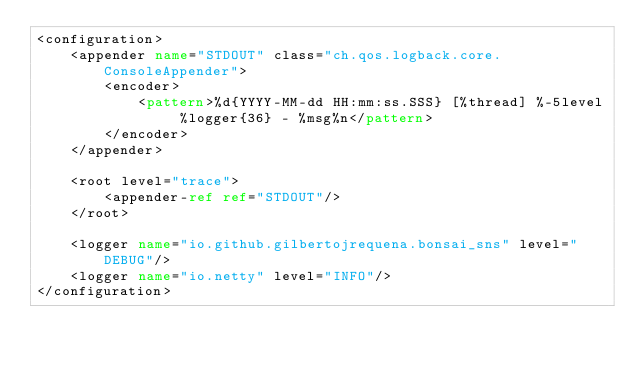<code> <loc_0><loc_0><loc_500><loc_500><_XML_><configuration>
    <appender name="STDOUT" class="ch.qos.logback.core.ConsoleAppender">
        <encoder>
            <pattern>%d{YYYY-MM-dd HH:mm:ss.SSS} [%thread] %-5level %logger{36} - %msg%n</pattern>
        </encoder>
    </appender>

    <root level="trace">
        <appender-ref ref="STDOUT"/>
    </root>

    <logger name="io.github.gilbertojrequena.bonsai_sns" level="DEBUG"/>
    <logger name="io.netty" level="INFO"/>
</configuration></code> 